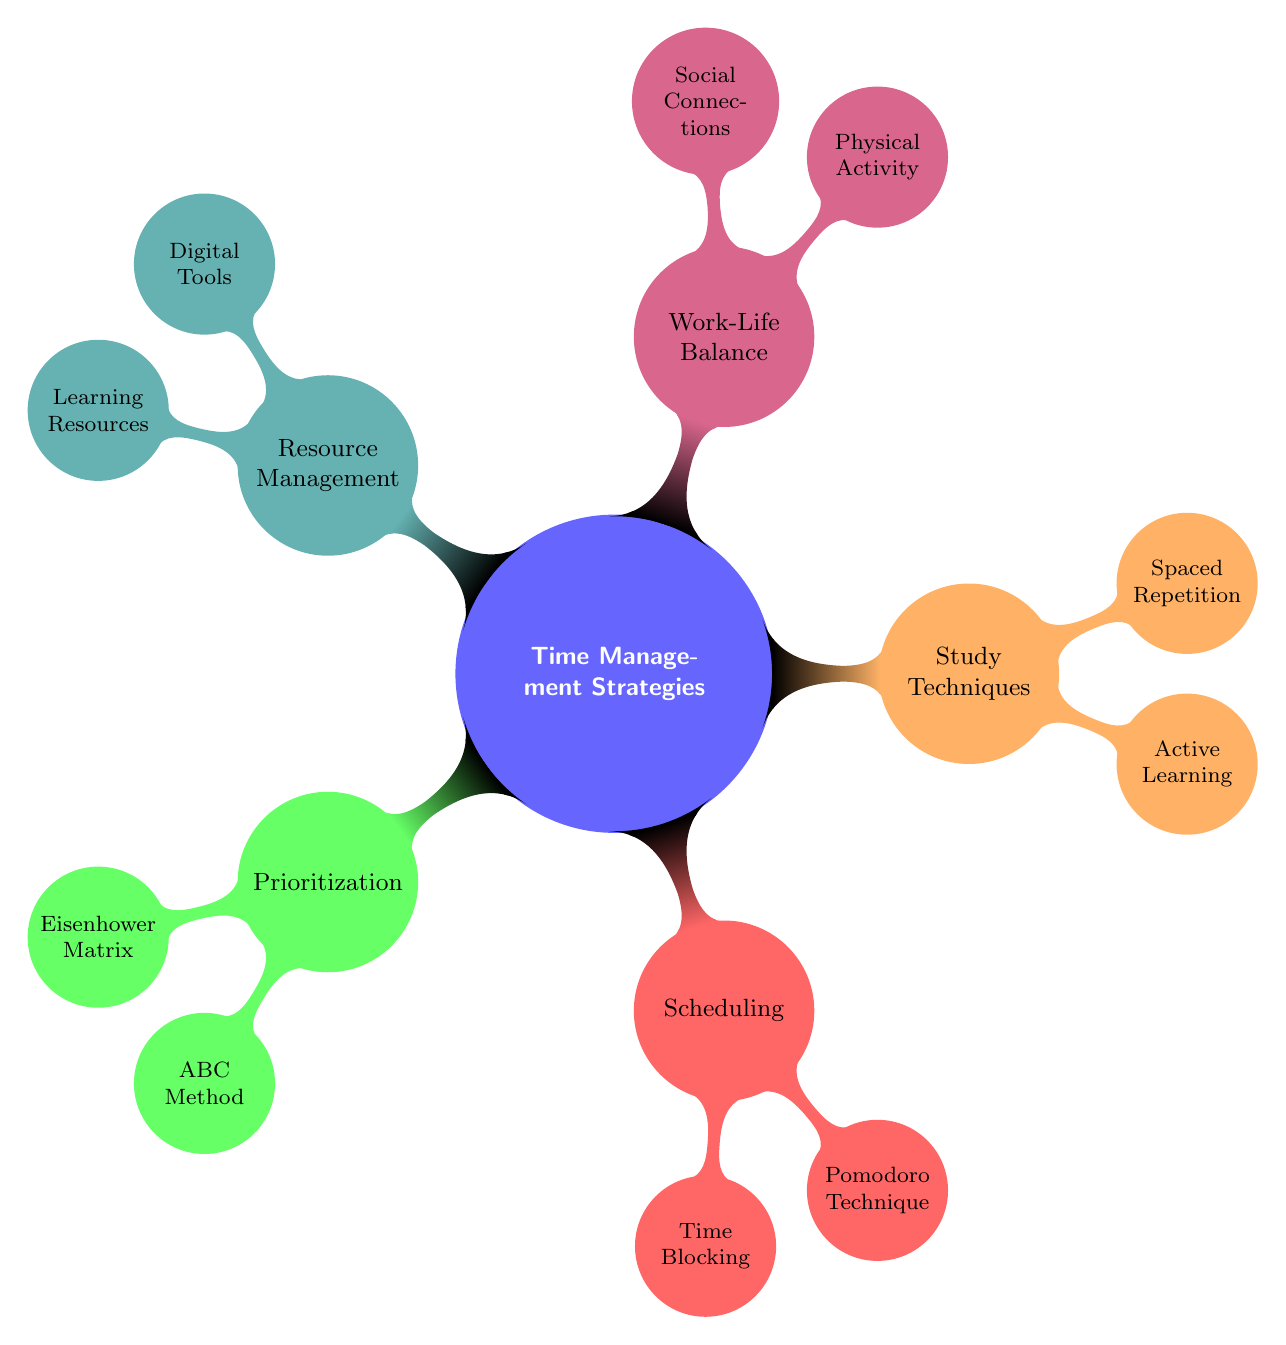What is the main topic of this mind map? The central theme of the mind map is indicated clearly at the center and refers to strategies for managing time effectively for medical students.
Answer: Time Management Strategies How many main branches does the diagram have? The main branches in the mind map are evident from the structure. There are five branches protruding from the central concept.
Answer: 5 What strategy is categorized under 'Work-Life Balance'? The 'Work-Life Balance' section shows two strategies listed below it; identifying one of them is straightforward based on the diagram content.
Answer: Physical Activity What technique is associated with scheduling? There are specific strategies listed under the 'Scheduling' branch, making it easy to identify a technique linked to this category.
Answer: Pomodoro Technique Which study technique encourages engagement with material? The study techniques branch features strategies, one of which emphasizes active engagement, making it a clear answer based on the displayed nodes.
Answer: Active Learning How many techniques are listed under 'Resource Management'? By counting the nodes under the 'Resource Management' branch, we can determine how many techniques are included in that category.
Answer: 2 Which prioritization method categorizes tasks based on urgency and importance? The 'Prioritization' section lists two methods, one of which specifically describes a matrix approach related to urgency and importance, leading to a clear response.
Answer: Eisenhower Matrix Which strategy helps improve retention through periodic review? In the 'Study Techniques' section, there is a specific method focused on reviewing material at increasing intervals, making this question directly answerable from the node descriptions.
Answer: Spaced Repetition What is a key benefit of scheduling with Time Blocking? While the map does not explicitly state benefits, it has descriptions under scheduling techniques; understanding time blocking implies dedicated time management for tasks.
Answer: Allocate specific time slots 